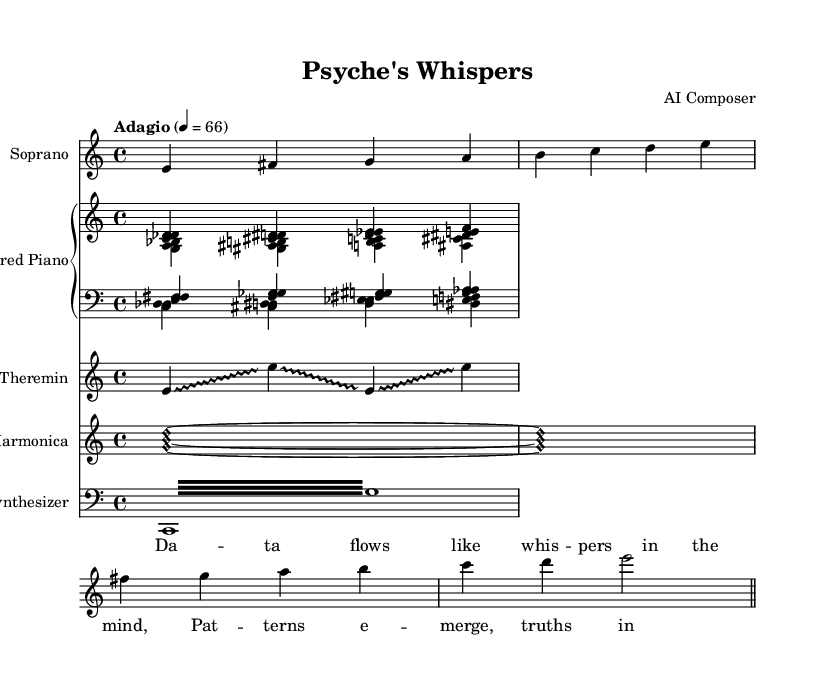What is the time signature of this music? The time signature is indicated at the beginning of the score as 4/4, which means there are four beats in each measure.
Answer: 4/4 What is the tempo marking in this piece? The tempo marking is specified as "Adagio" with a metronome marking of 66, indicating a slow tempo.
Answer: Adagio How many instruments are used in this composition? The score includes five unique instruments: Soprano, Prepared Piano, Theremin, Glass Harmonica, and Synthesizer.
Answer: Five What are the first lyrics sung in this opera? The lyrics at the start of the score are "Da -- ta flows like whis -- pers in the mind," which are sung by the Soprano.
Answer: "Da -- ta flows like whis -- pers in the mind." Which unconventional instrument represents glissando effects in the score? The Theremin is the instrument specifically indicated to use the glissando style to create its unique sound effects.
Answer: Theremin What type of harmonics is used in the Glass Harmonica part? The notation for the Glass Harmonica uses harmonic note heads, indicating that it produces a specific type of sound that is different from conventional notes.
Answer: Harmonic How many measures are in the Soprano part? The Soprano part contains a total of four measures, indicated by the notation given in that staff.
Answer: Four 